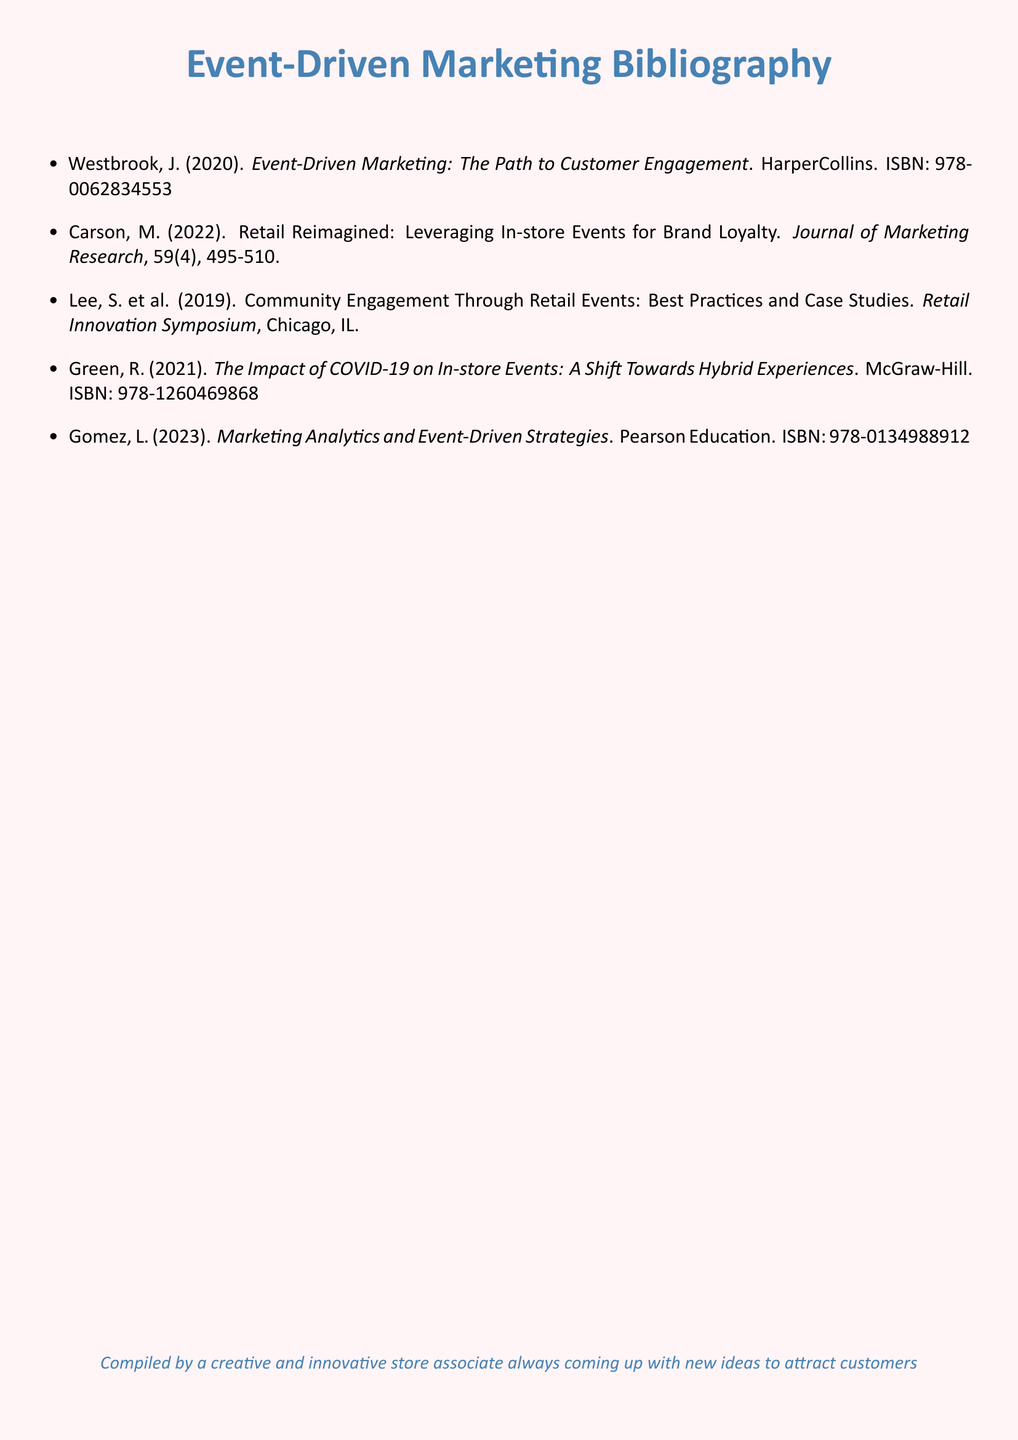what is the title of the first reference? The title of the first reference is the one listed immediately after the author's name.
Answer: Event-Driven Marketing: The Path to Customer Engagement who authored the document from 2023? The author for the document published in 2023 is the last one listed in the document.
Answer: Gomez, L what year was the reference by Green published? The publication year is provided directly after the author's name in the reference.
Answer: 2021 how many articles or books are listed in total? The total count is determined by counting each item in the reference list.
Answer: 5 which publisher produced the book by Westbrook? The publisher is mentioned directly after the title in the reference entry.
Answer: HarperCollins what is the topic of the second reference? The topic of the second reference is summarized in the title of the article.
Answer: Leveraging In-store Events for Brand Loyalty who presented at the Retail Innovation Symposium? The authors of the specific case study provide the necessary information.
Answer: Lee, S. et al what type of experiences are discussed in Green's work? The type of experiences is identified in the title of the book.
Answer: Hybrid experiences 